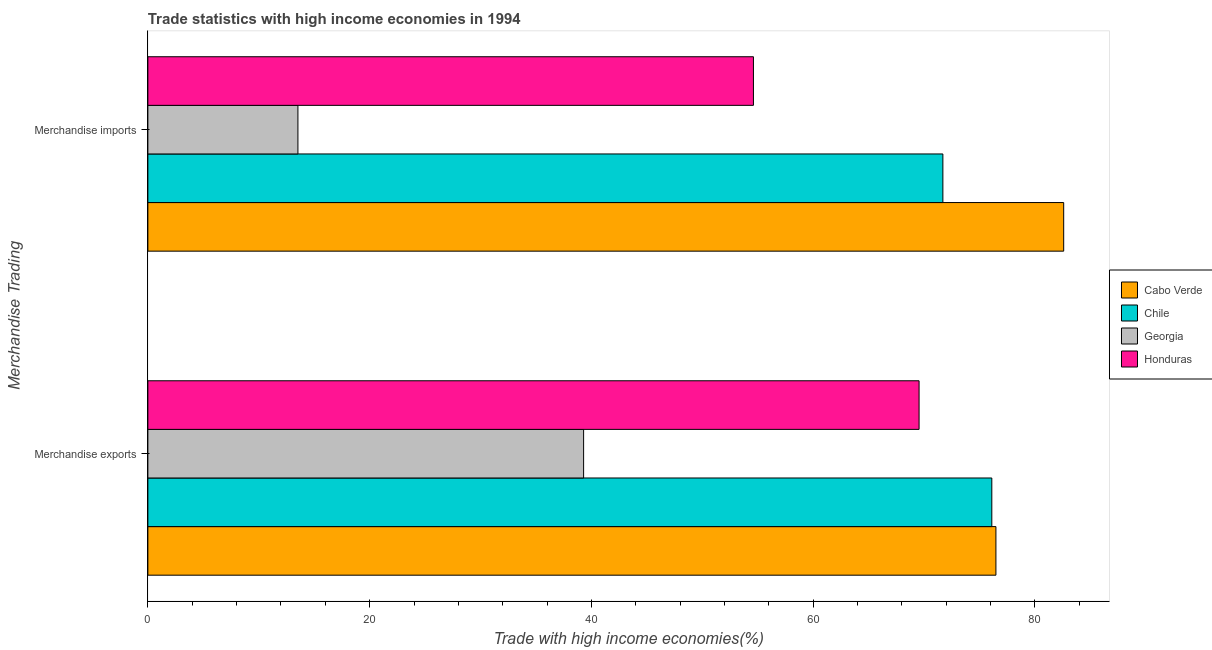How many groups of bars are there?
Offer a terse response. 2. How many bars are there on the 2nd tick from the bottom?
Offer a very short reply. 4. What is the merchandise imports in Georgia?
Make the answer very short. 13.53. Across all countries, what is the maximum merchandise exports?
Keep it short and to the point. 76.48. Across all countries, what is the minimum merchandise imports?
Make the answer very short. 13.53. In which country was the merchandise imports maximum?
Provide a succinct answer. Cabo Verde. In which country was the merchandise exports minimum?
Your response must be concise. Georgia. What is the total merchandise imports in the graph?
Offer a very short reply. 222.43. What is the difference between the merchandise imports in Honduras and that in Georgia?
Give a very brief answer. 41.08. What is the difference between the merchandise exports in Georgia and the merchandise imports in Cabo Verde?
Provide a short and direct response. -43.29. What is the average merchandise exports per country?
Ensure brevity in your answer.  65.36. What is the difference between the merchandise exports and merchandise imports in Georgia?
Keep it short and to the point. 25.76. What is the ratio of the merchandise exports in Cabo Verde to that in Honduras?
Your answer should be very brief. 1.1. In how many countries, is the merchandise imports greater than the average merchandise imports taken over all countries?
Make the answer very short. 2. What does the 4th bar from the top in Merchandise imports represents?
Your response must be concise. Cabo Verde. What does the 1st bar from the bottom in Merchandise imports represents?
Make the answer very short. Cabo Verde. How many bars are there?
Keep it short and to the point. 8. Are all the bars in the graph horizontal?
Provide a succinct answer. Yes. How many countries are there in the graph?
Ensure brevity in your answer.  4. Are the values on the major ticks of X-axis written in scientific E-notation?
Provide a short and direct response. No. Does the graph contain any zero values?
Ensure brevity in your answer.  No. Does the graph contain grids?
Ensure brevity in your answer.  No. How many legend labels are there?
Your answer should be very brief. 4. What is the title of the graph?
Ensure brevity in your answer.  Trade statistics with high income economies in 1994. Does "Macedonia" appear as one of the legend labels in the graph?
Ensure brevity in your answer.  No. What is the label or title of the X-axis?
Your answer should be compact. Trade with high income economies(%). What is the label or title of the Y-axis?
Your response must be concise. Merchandise Trading. What is the Trade with high income economies(%) of Cabo Verde in Merchandise exports?
Give a very brief answer. 76.48. What is the Trade with high income economies(%) of Chile in Merchandise exports?
Keep it short and to the point. 76.11. What is the Trade with high income economies(%) of Georgia in Merchandise exports?
Offer a very short reply. 39.3. What is the Trade with high income economies(%) of Honduras in Merchandise exports?
Your response must be concise. 69.55. What is the Trade with high income economies(%) in Cabo Verde in Merchandise imports?
Offer a terse response. 82.59. What is the Trade with high income economies(%) in Chile in Merchandise imports?
Offer a terse response. 71.69. What is the Trade with high income economies(%) in Georgia in Merchandise imports?
Your answer should be very brief. 13.53. What is the Trade with high income economies(%) of Honduras in Merchandise imports?
Provide a succinct answer. 54.61. Across all Merchandise Trading, what is the maximum Trade with high income economies(%) of Cabo Verde?
Offer a very short reply. 82.59. Across all Merchandise Trading, what is the maximum Trade with high income economies(%) in Chile?
Offer a very short reply. 76.11. Across all Merchandise Trading, what is the maximum Trade with high income economies(%) in Georgia?
Offer a very short reply. 39.3. Across all Merchandise Trading, what is the maximum Trade with high income economies(%) of Honduras?
Make the answer very short. 69.55. Across all Merchandise Trading, what is the minimum Trade with high income economies(%) of Cabo Verde?
Keep it short and to the point. 76.48. Across all Merchandise Trading, what is the minimum Trade with high income economies(%) in Chile?
Your answer should be very brief. 71.69. Across all Merchandise Trading, what is the minimum Trade with high income economies(%) of Georgia?
Provide a short and direct response. 13.53. Across all Merchandise Trading, what is the minimum Trade with high income economies(%) of Honduras?
Your response must be concise. 54.61. What is the total Trade with high income economies(%) of Cabo Verde in the graph?
Provide a short and direct response. 159.07. What is the total Trade with high income economies(%) of Chile in the graph?
Your response must be concise. 147.8. What is the total Trade with high income economies(%) of Georgia in the graph?
Ensure brevity in your answer.  52.83. What is the total Trade with high income economies(%) in Honduras in the graph?
Your answer should be compact. 124.16. What is the difference between the Trade with high income economies(%) in Cabo Verde in Merchandise exports and that in Merchandise imports?
Your answer should be compact. -6.11. What is the difference between the Trade with high income economies(%) in Chile in Merchandise exports and that in Merchandise imports?
Provide a succinct answer. 4.41. What is the difference between the Trade with high income economies(%) of Georgia in Merchandise exports and that in Merchandise imports?
Provide a short and direct response. 25.76. What is the difference between the Trade with high income economies(%) in Honduras in Merchandise exports and that in Merchandise imports?
Make the answer very short. 14.94. What is the difference between the Trade with high income economies(%) of Cabo Verde in Merchandise exports and the Trade with high income economies(%) of Chile in Merchandise imports?
Give a very brief answer. 4.78. What is the difference between the Trade with high income economies(%) in Cabo Verde in Merchandise exports and the Trade with high income economies(%) in Georgia in Merchandise imports?
Offer a very short reply. 62.95. What is the difference between the Trade with high income economies(%) in Cabo Verde in Merchandise exports and the Trade with high income economies(%) in Honduras in Merchandise imports?
Your response must be concise. 21.87. What is the difference between the Trade with high income economies(%) of Chile in Merchandise exports and the Trade with high income economies(%) of Georgia in Merchandise imports?
Ensure brevity in your answer.  62.58. What is the difference between the Trade with high income economies(%) in Chile in Merchandise exports and the Trade with high income economies(%) in Honduras in Merchandise imports?
Your answer should be compact. 21.5. What is the difference between the Trade with high income economies(%) in Georgia in Merchandise exports and the Trade with high income economies(%) in Honduras in Merchandise imports?
Make the answer very short. -15.31. What is the average Trade with high income economies(%) of Cabo Verde per Merchandise Trading?
Make the answer very short. 79.53. What is the average Trade with high income economies(%) in Chile per Merchandise Trading?
Give a very brief answer. 73.9. What is the average Trade with high income economies(%) of Georgia per Merchandise Trading?
Ensure brevity in your answer.  26.41. What is the average Trade with high income economies(%) in Honduras per Merchandise Trading?
Your answer should be compact. 62.08. What is the difference between the Trade with high income economies(%) in Cabo Verde and Trade with high income economies(%) in Chile in Merchandise exports?
Ensure brevity in your answer.  0.37. What is the difference between the Trade with high income economies(%) in Cabo Verde and Trade with high income economies(%) in Georgia in Merchandise exports?
Provide a short and direct response. 37.18. What is the difference between the Trade with high income economies(%) of Cabo Verde and Trade with high income economies(%) of Honduras in Merchandise exports?
Give a very brief answer. 6.93. What is the difference between the Trade with high income economies(%) in Chile and Trade with high income economies(%) in Georgia in Merchandise exports?
Ensure brevity in your answer.  36.81. What is the difference between the Trade with high income economies(%) of Chile and Trade with high income economies(%) of Honduras in Merchandise exports?
Offer a very short reply. 6.56. What is the difference between the Trade with high income economies(%) of Georgia and Trade with high income economies(%) of Honduras in Merchandise exports?
Make the answer very short. -30.25. What is the difference between the Trade with high income economies(%) in Cabo Verde and Trade with high income economies(%) in Chile in Merchandise imports?
Keep it short and to the point. 10.89. What is the difference between the Trade with high income economies(%) of Cabo Verde and Trade with high income economies(%) of Georgia in Merchandise imports?
Your answer should be compact. 69.06. What is the difference between the Trade with high income economies(%) in Cabo Verde and Trade with high income economies(%) in Honduras in Merchandise imports?
Your response must be concise. 27.98. What is the difference between the Trade with high income economies(%) in Chile and Trade with high income economies(%) in Georgia in Merchandise imports?
Give a very brief answer. 58.16. What is the difference between the Trade with high income economies(%) in Chile and Trade with high income economies(%) in Honduras in Merchandise imports?
Offer a terse response. 17.08. What is the difference between the Trade with high income economies(%) of Georgia and Trade with high income economies(%) of Honduras in Merchandise imports?
Offer a very short reply. -41.08. What is the ratio of the Trade with high income economies(%) of Cabo Verde in Merchandise exports to that in Merchandise imports?
Make the answer very short. 0.93. What is the ratio of the Trade with high income economies(%) of Chile in Merchandise exports to that in Merchandise imports?
Your response must be concise. 1.06. What is the ratio of the Trade with high income economies(%) in Georgia in Merchandise exports to that in Merchandise imports?
Make the answer very short. 2.9. What is the ratio of the Trade with high income economies(%) of Honduras in Merchandise exports to that in Merchandise imports?
Provide a succinct answer. 1.27. What is the difference between the highest and the second highest Trade with high income economies(%) of Cabo Verde?
Provide a succinct answer. 6.11. What is the difference between the highest and the second highest Trade with high income economies(%) in Chile?
Offer a very short reply. 4.41. What is the difference between the highest and the second highest Trade with high income economies(%) in Georgia?
Ensure brevity in your answer.  25.76. What is the difference between the highest and the second highest Trade with high income economies(%) in Honduras?
Offer a terse response. 14.94. What is the difference between the highest and the lowest Trade with high income economies(%) in Cabo Verde?
Your answer should be very brief. 6.11. What is the difference between the highest and the lowest Trade with high income economies(%) of Chile?
Give a very brief answer. 4.41. What is the difference between the highest and the lowest Trade with high income economies(%) in Georgia?
Keep it short and to the point. 25.76. What is the difference between the highest and the lowest Trade with high income economies(%) of Honduras?
Provide a short and direct response. 14.94. 